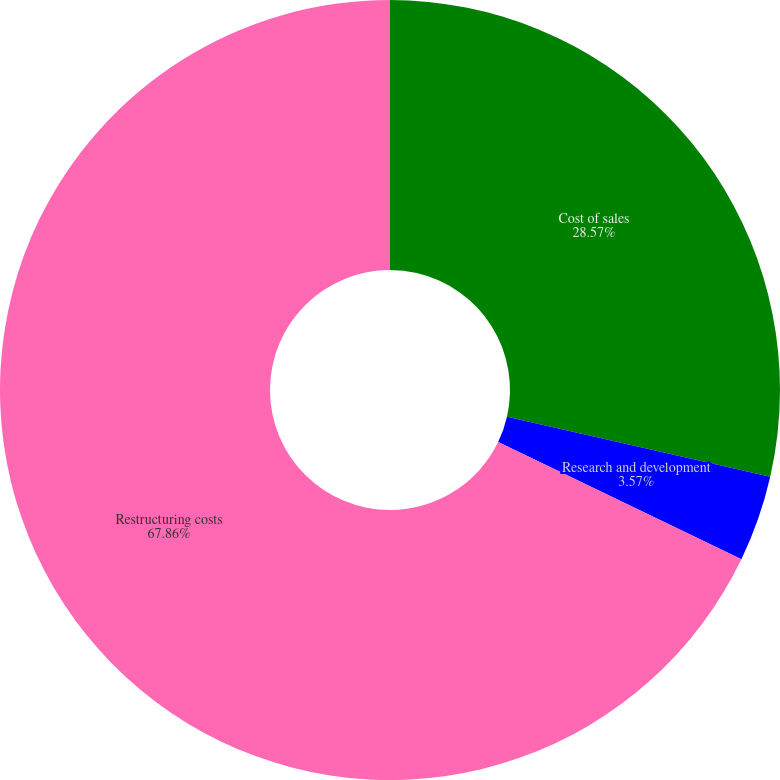<chart> <loc_0><loc_0><loc_500><loc_500><pie_chart><fcel>Cost of sales<fcel>Research and development<fcel>Restructuring costs<nl><fcel>28.57%<fcel>3.57%<fcel>67.86%<nl></chart> 